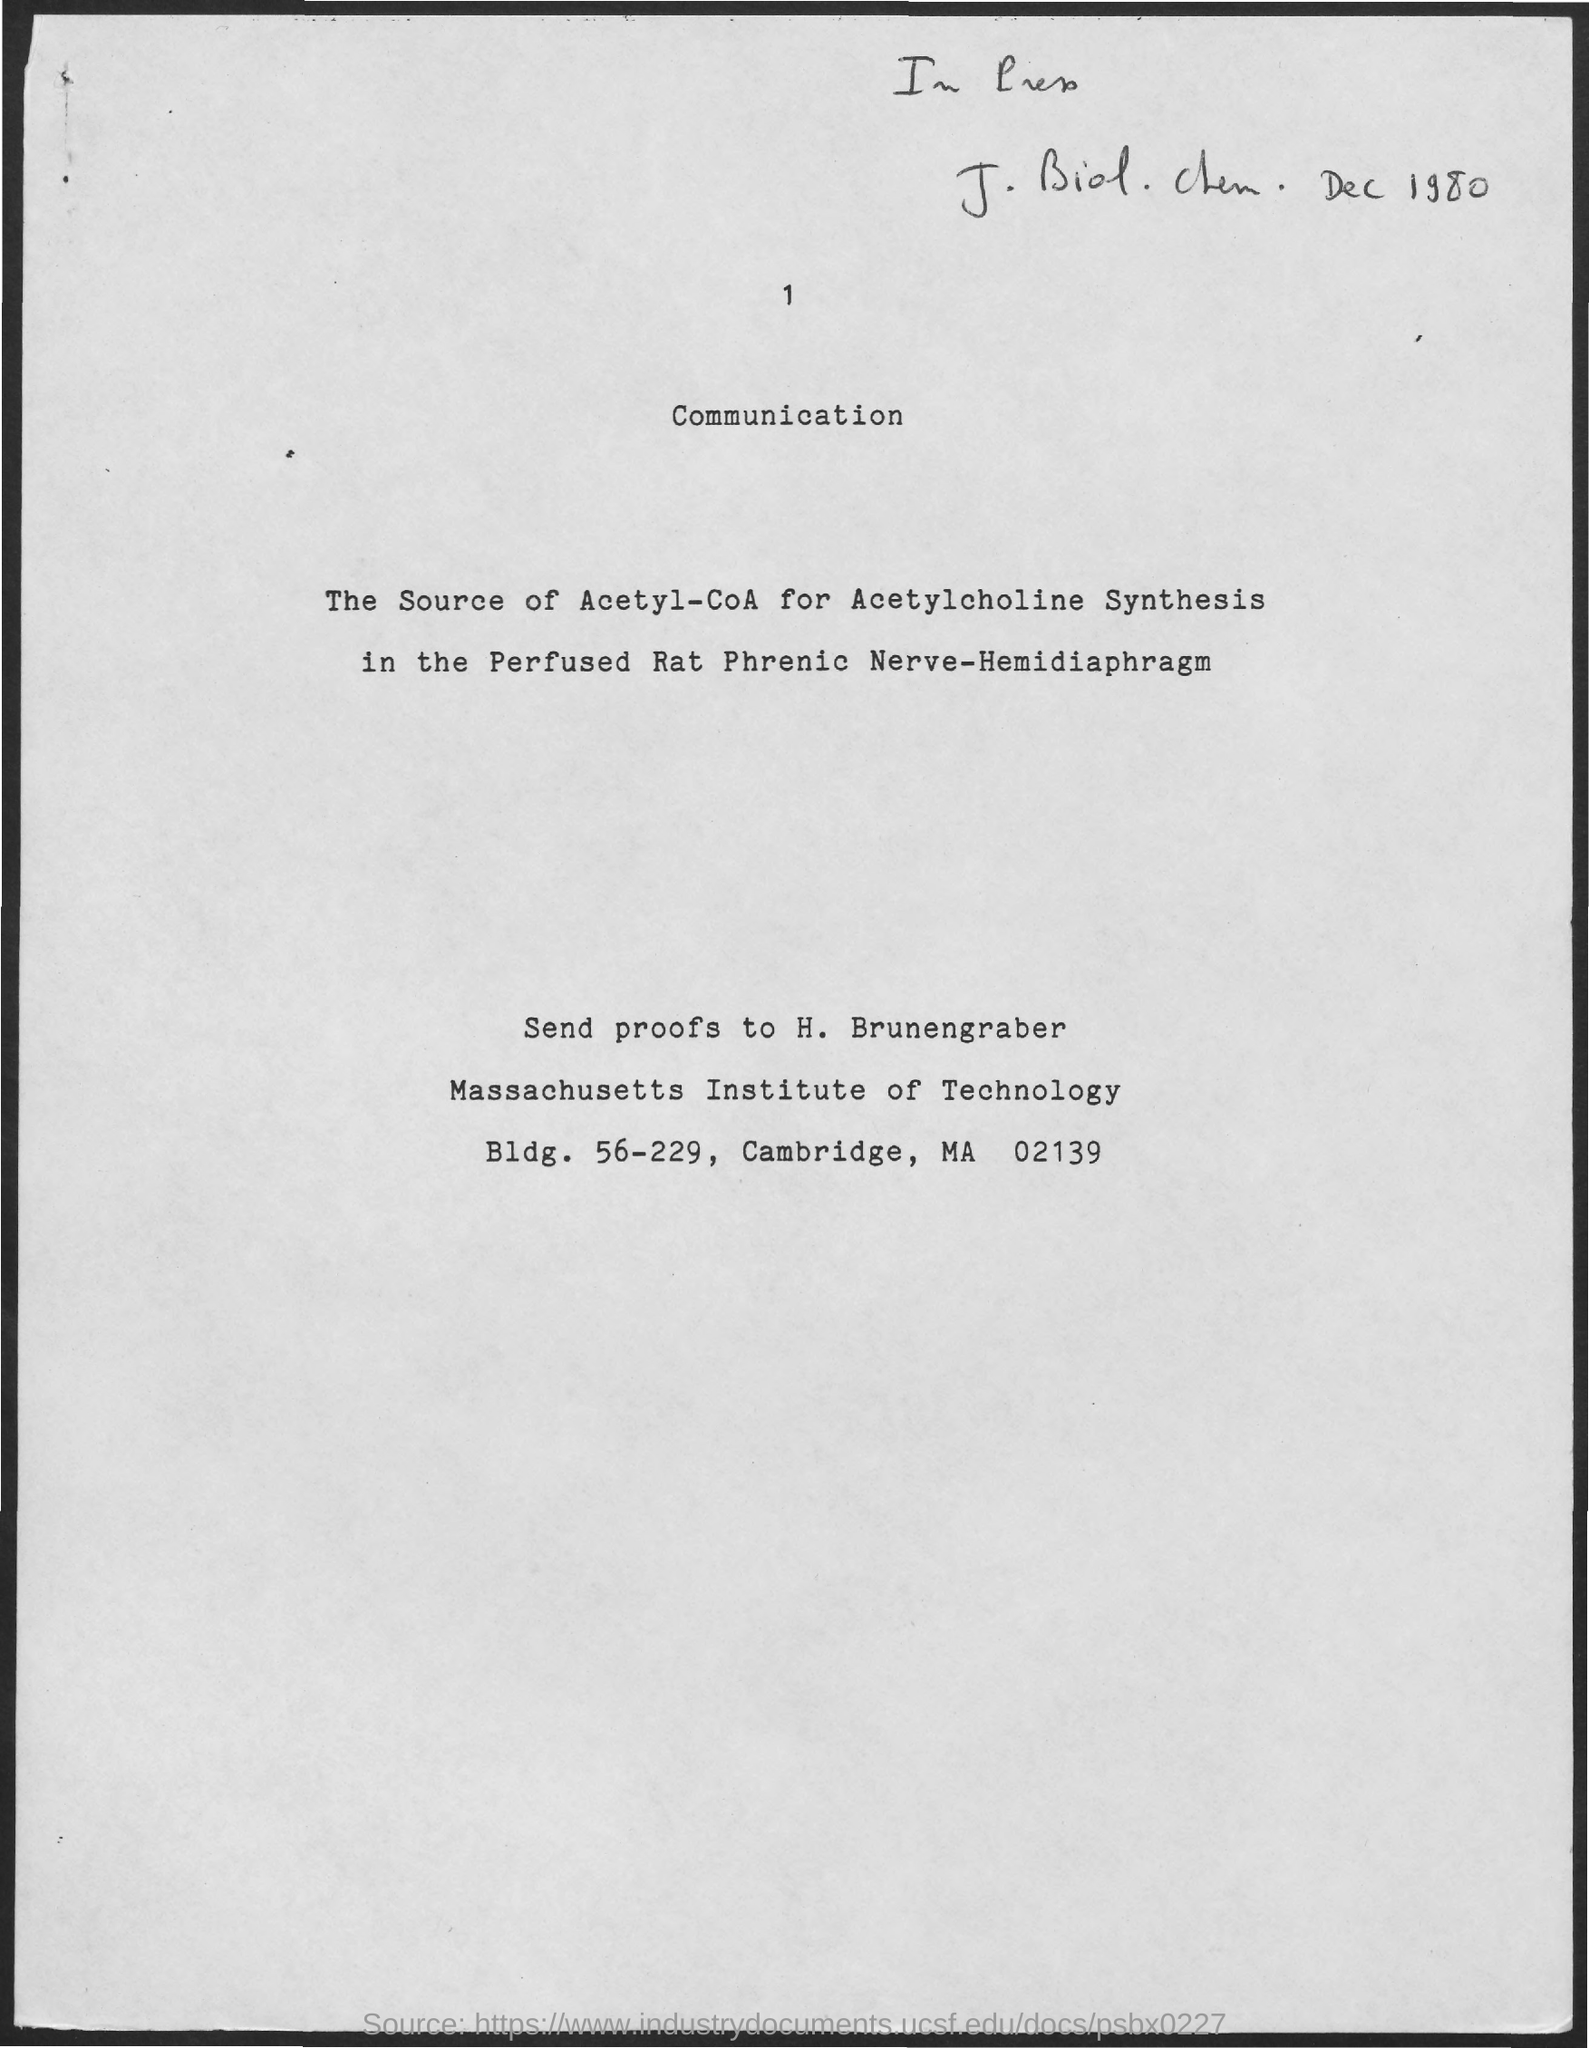What is the heading of page?
Give a very brief answer. Communication. What is the page number at top of page?
Ensure brevity in your answer.  1. To whom must the proofs should be sent to?
Keep it short and to the point. H. Brunengraber. 